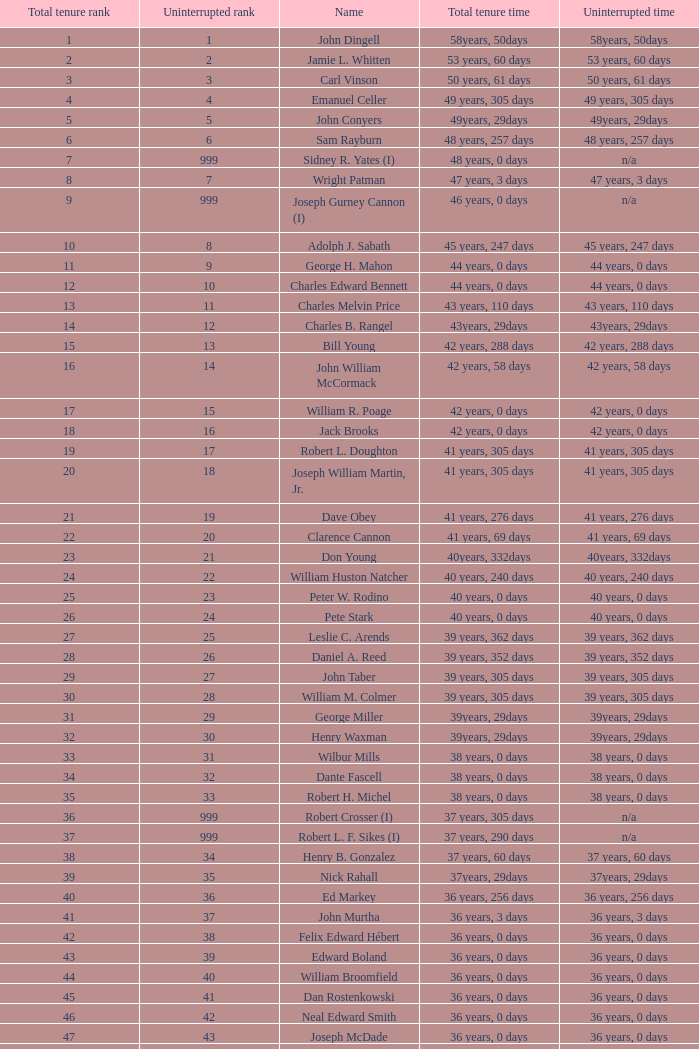How many uninterrupted ranks does john dingell have? 1.0. 